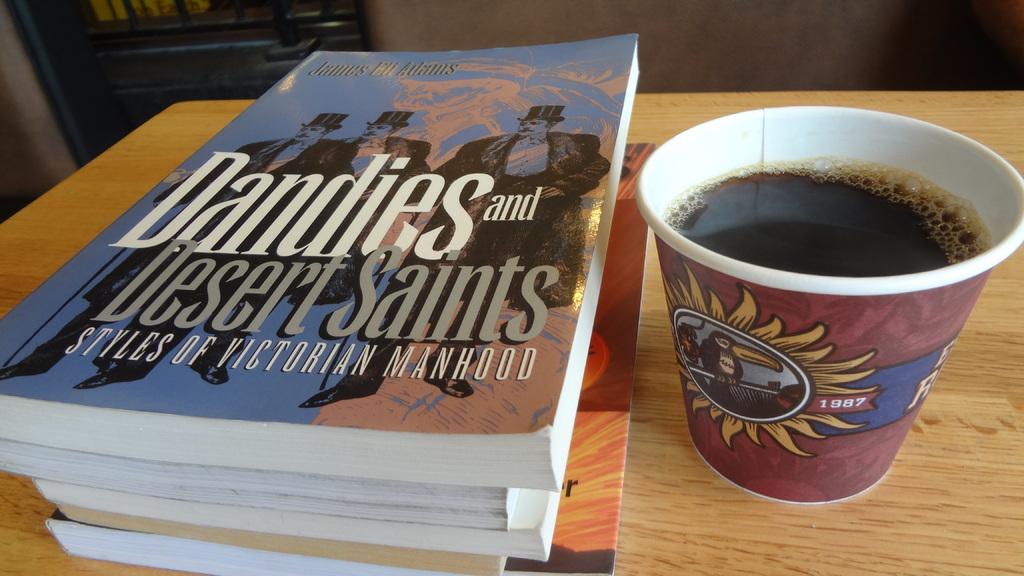Is dandies and desert saints a book?
Provide a short and direct response. Yes. What year is printed on the coffee cup?
Offer a terse response. 1987. 